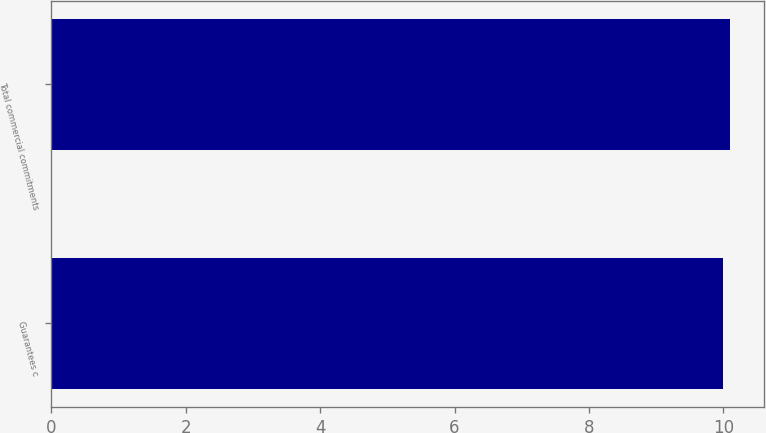Convert chart. <chart><loc_0><loc_0><loc_500><loc_500><bar_chart><fcel>Guarantees c<fcel>Total commercial commitments<nl><fcel>10<fcel>10.1<nl></chart> 